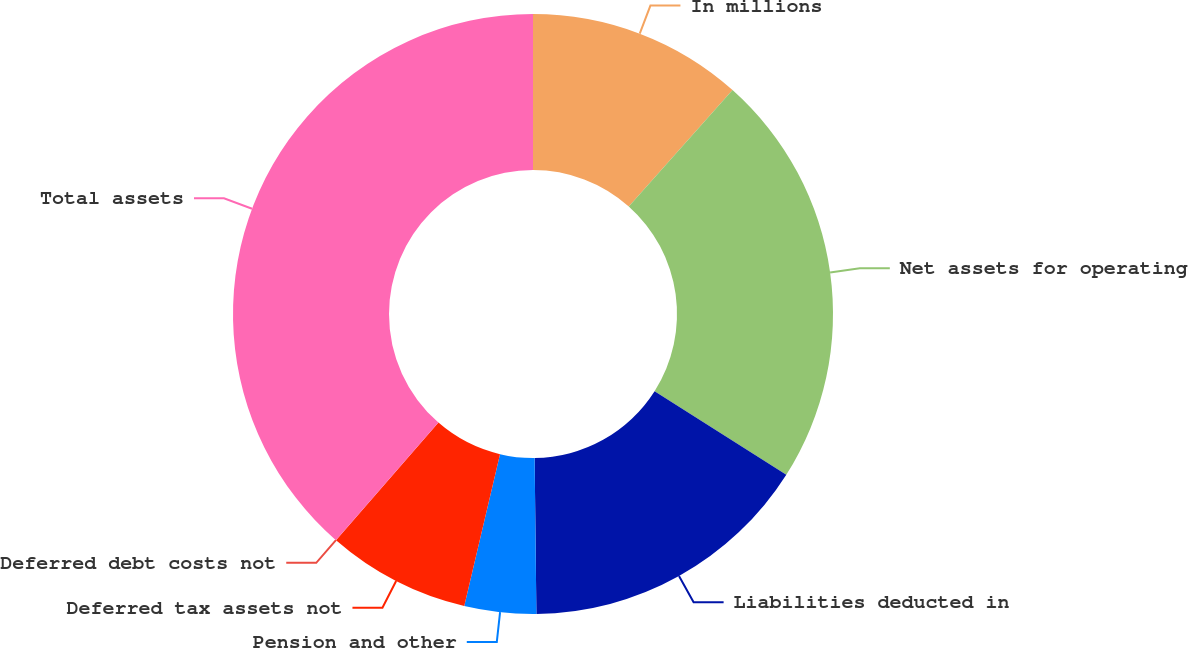Convert chart to OTSL. <chart><loc_0><loc_0><loc_500><loc_500><pie_chart><fcel>In millions<fcel>Net assets for operating<fcel>Liabilities deducted in<fcel>Pension and other<fcel>Deferred tax assets not<fcel>Deferred debt costs not<fcel>Total assets<nl><fcel>11.58%<fcel>22.42%<fcel>15.82%<fcel>3.86%<fcel>7.72%<fcel>0.01%<fcel>38.59%<nl></chart> 